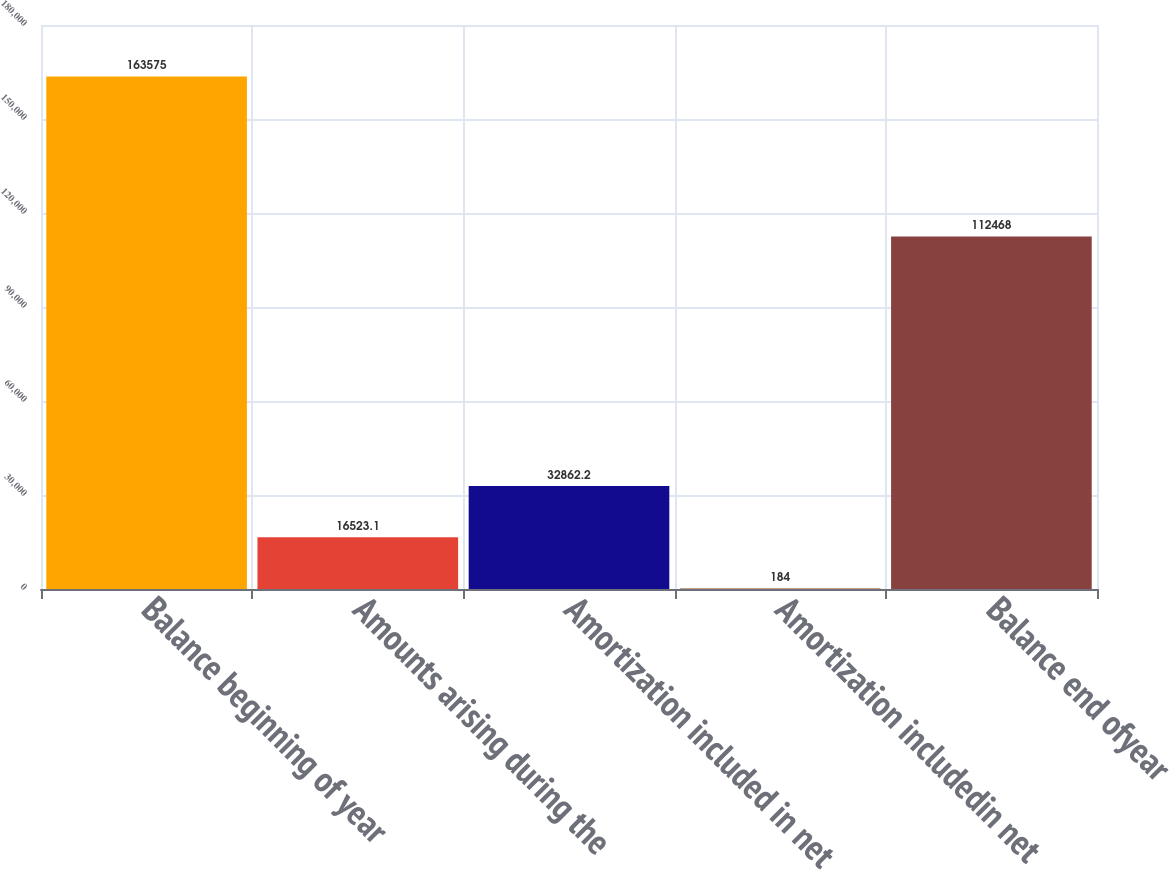Convert chart. <chart><loc_0><loc_0><loc_500><loc_500><bar_chart><fcel>Balance beginning of year<fcel>Amounts arising during the<fcel>Amortization included in net<fcel>Amortization includedin net<fcel>Balance end ofyear<nl><fcel>163575<fcel>16523.1<fcel>32862.2<fcel>184<fcel>112468<nl></chart> 